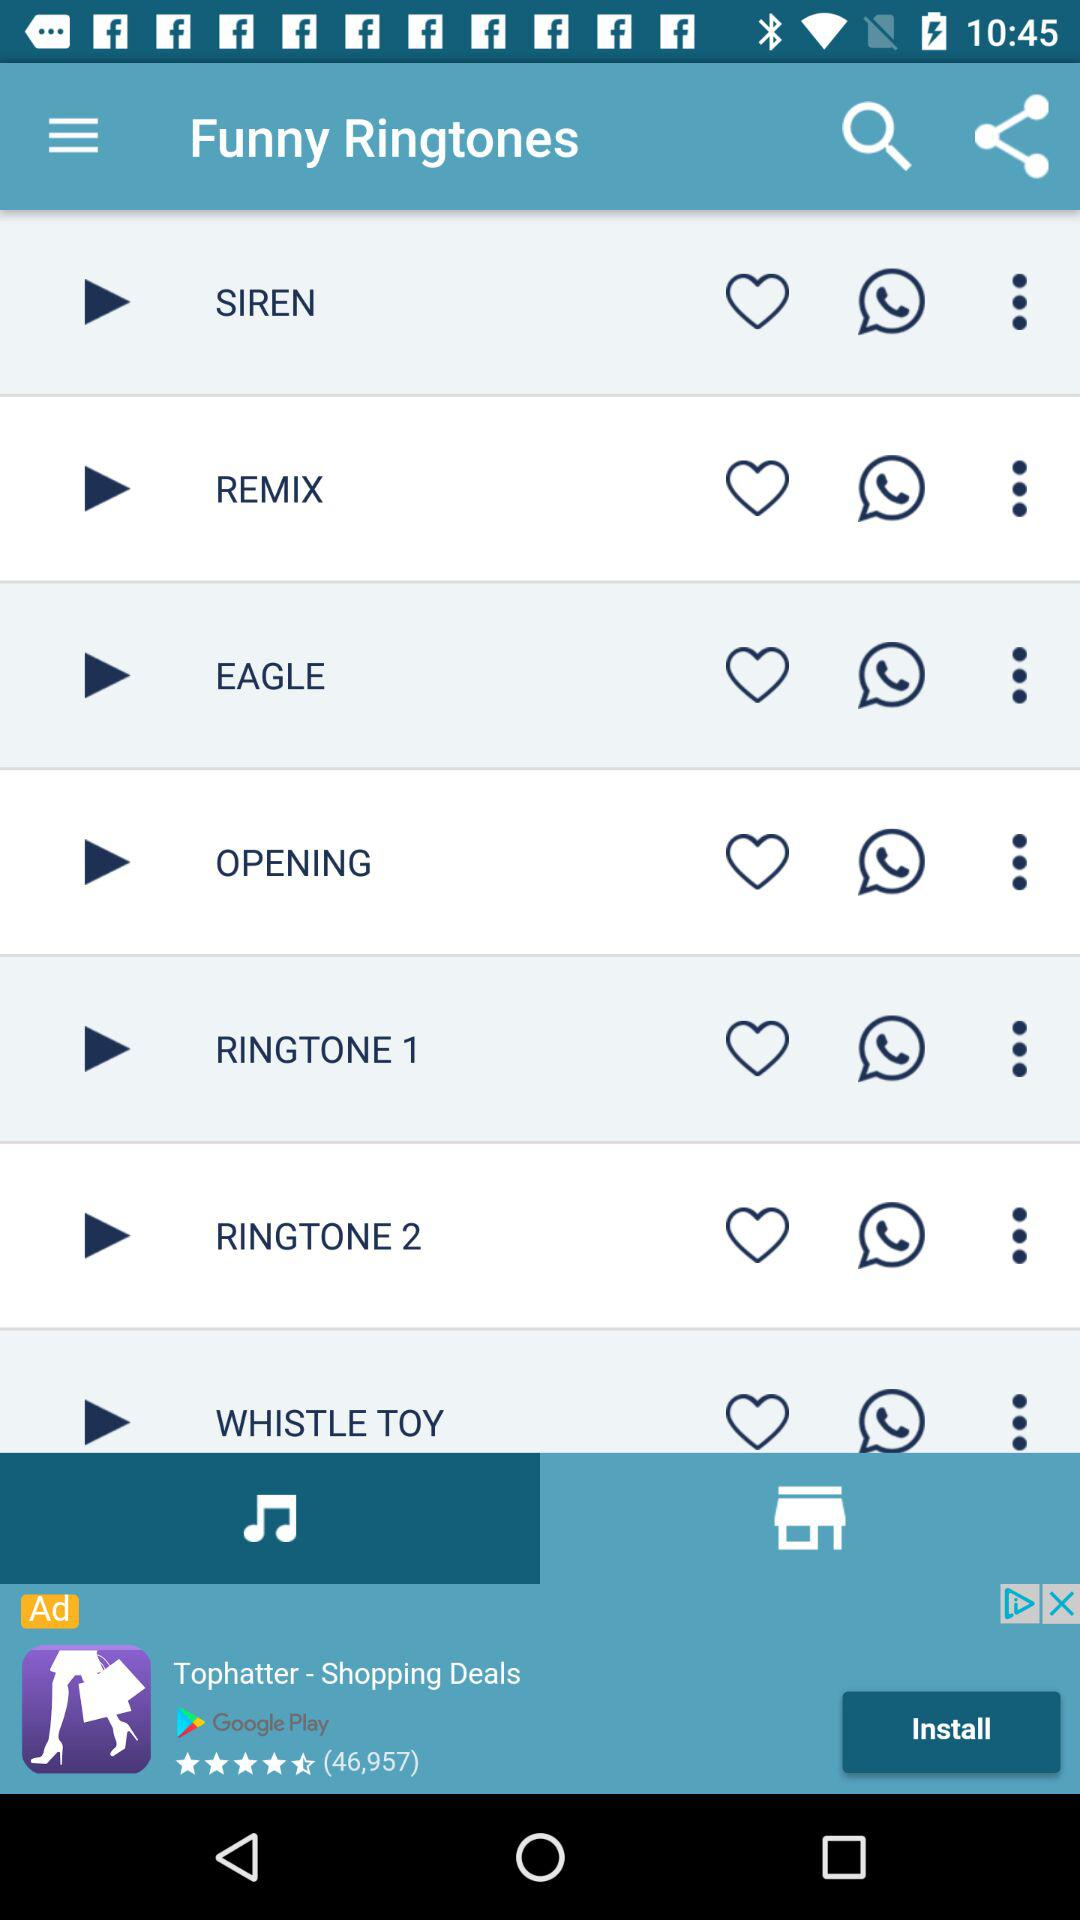What is the name of the application? The name of the application is "Funny Ringtones". 